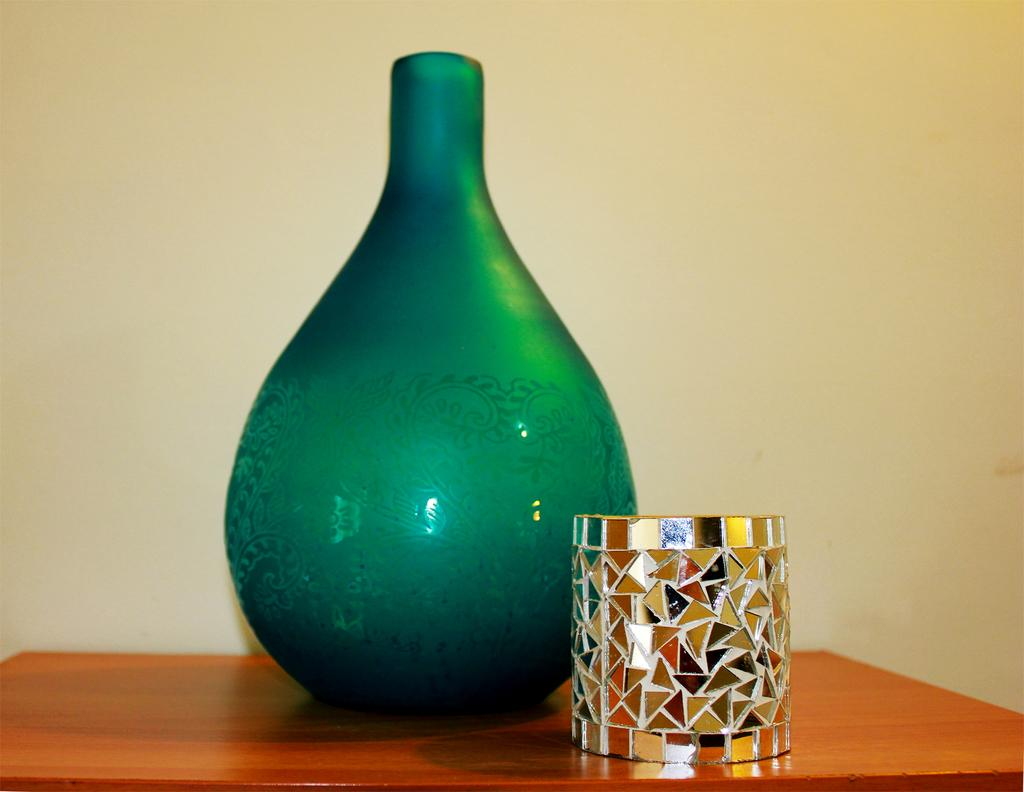What is present on the table in the image? There is a flower vase and a pen stand on the table in the image. What is the purpose of the pen stand? The pen stand is used to hold pens or other writing instruments. What can be seen on the wall in the image? There is a design on the wall in the image. What is visible in the background of the image? There is a wall visible in the background of the image. What type of tea is being prepared in the kettle in the image? There is no kettle present in the image, so it is not possible to determine what type of tea might be prepared. 